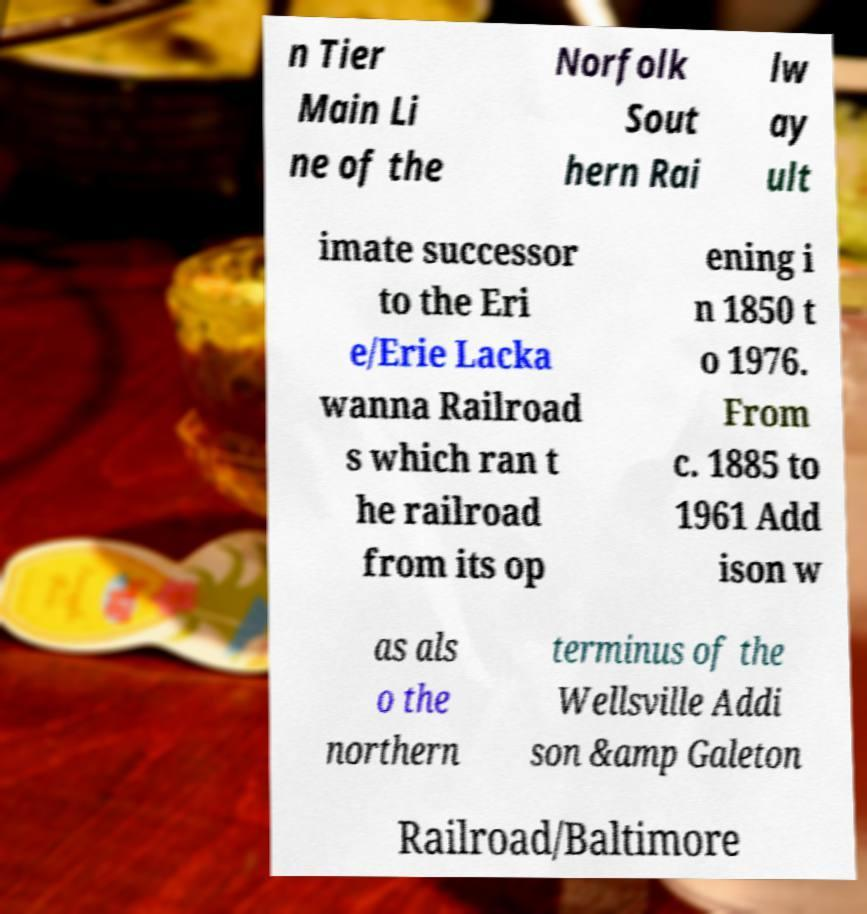I need the written content from this picture converted into text. Can you do that? n Tier Main Li ne of the Norfolk Sout hern Rai lw ay ult imate successor to the Eri e/Erie Lacka wanna Railroad s which ran t he railroad from its op ening i n 1850 t o 1976. From c. 1885 to 1961 Add ison w as als o the northern terminus of the Wellsville Addi son &amp Galeton Railroad/Baltimore 